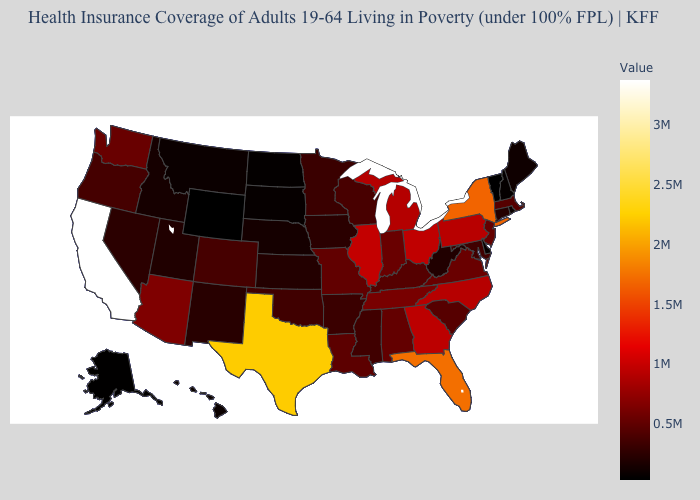Among the states that border Utah , does Arizona have the highest value?
Keep it brief. Yes. Does Wyoming have the lowest value in the USA?
Quick response, please. Yes. Which states have the highest value in the USA?
Give a very brief answer. California. Does Vermont have the highest value in the Northeast?
Keep it brief. No. 